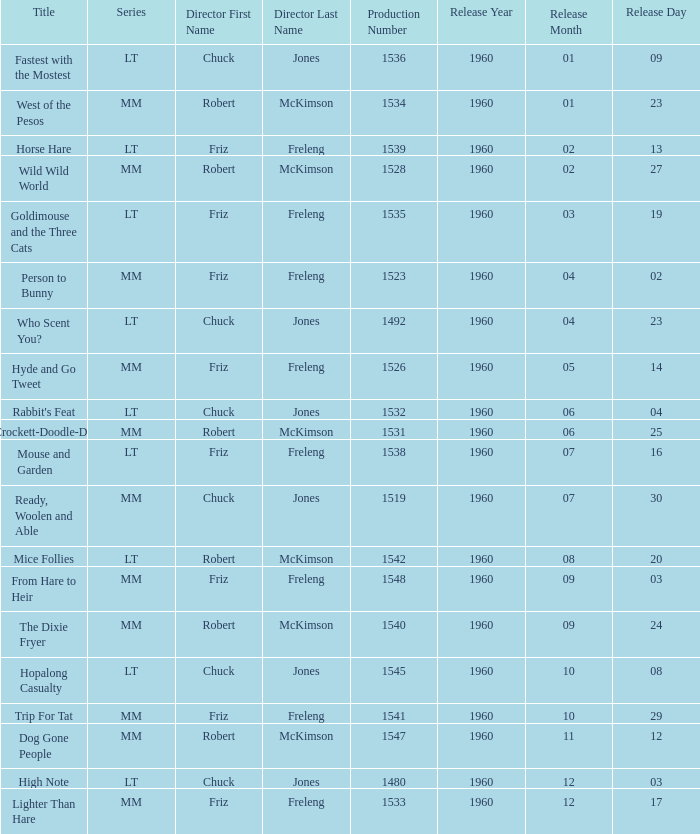What is the Series number of the episode with a production number of 1547? MM. 